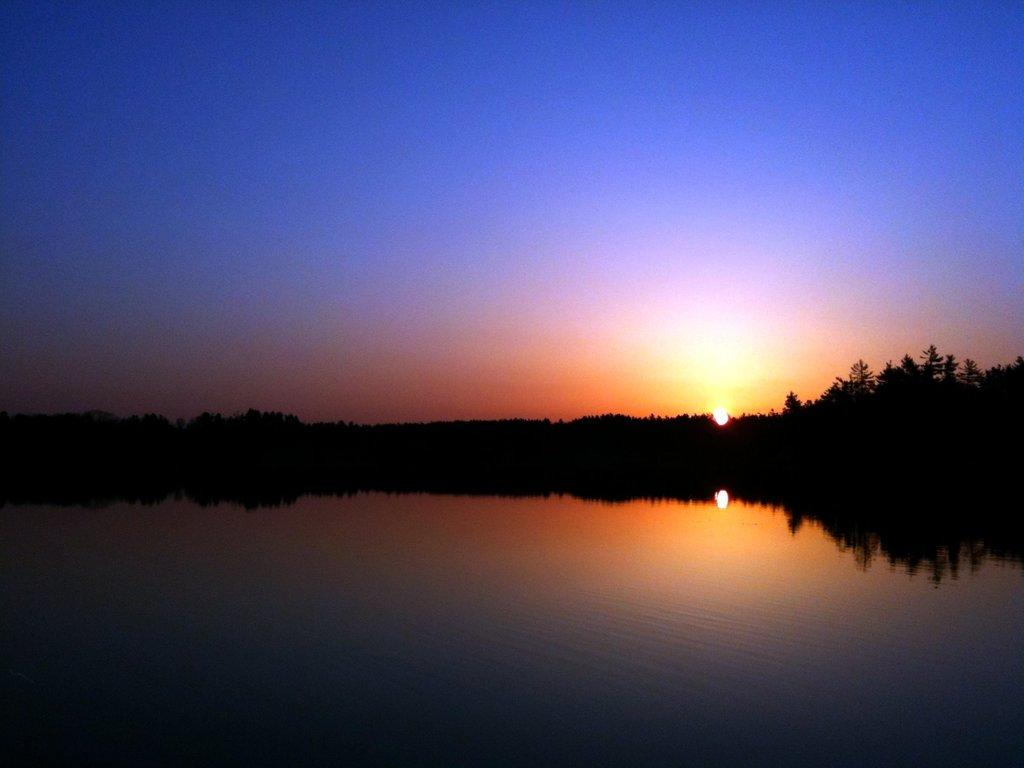What is the primary element visible in the picture? There is water in the picture. What can be seen in the distance beyond the water? There are trees visible in the distance. What celestial body is observable in the picture? The sun is observable in the picture. What is the color of the sky in the image? The sky is blue in color. What type of leaf is floating on the water in the image? There is no leaf visible in the image; it only features water, trees in the distance, the sun, and a blue sky. 